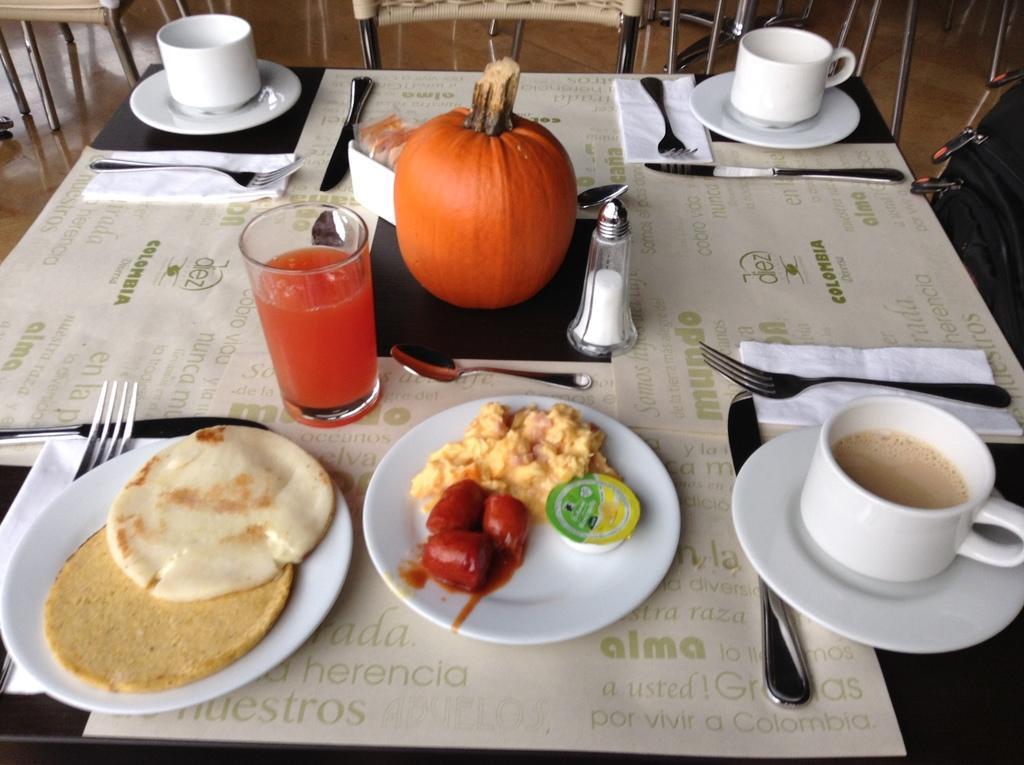Please provide a concise description of this image. In this image I can see few cups, plates, few forks, knives, a glass and food in plates. I can also see few chairs and a table. 